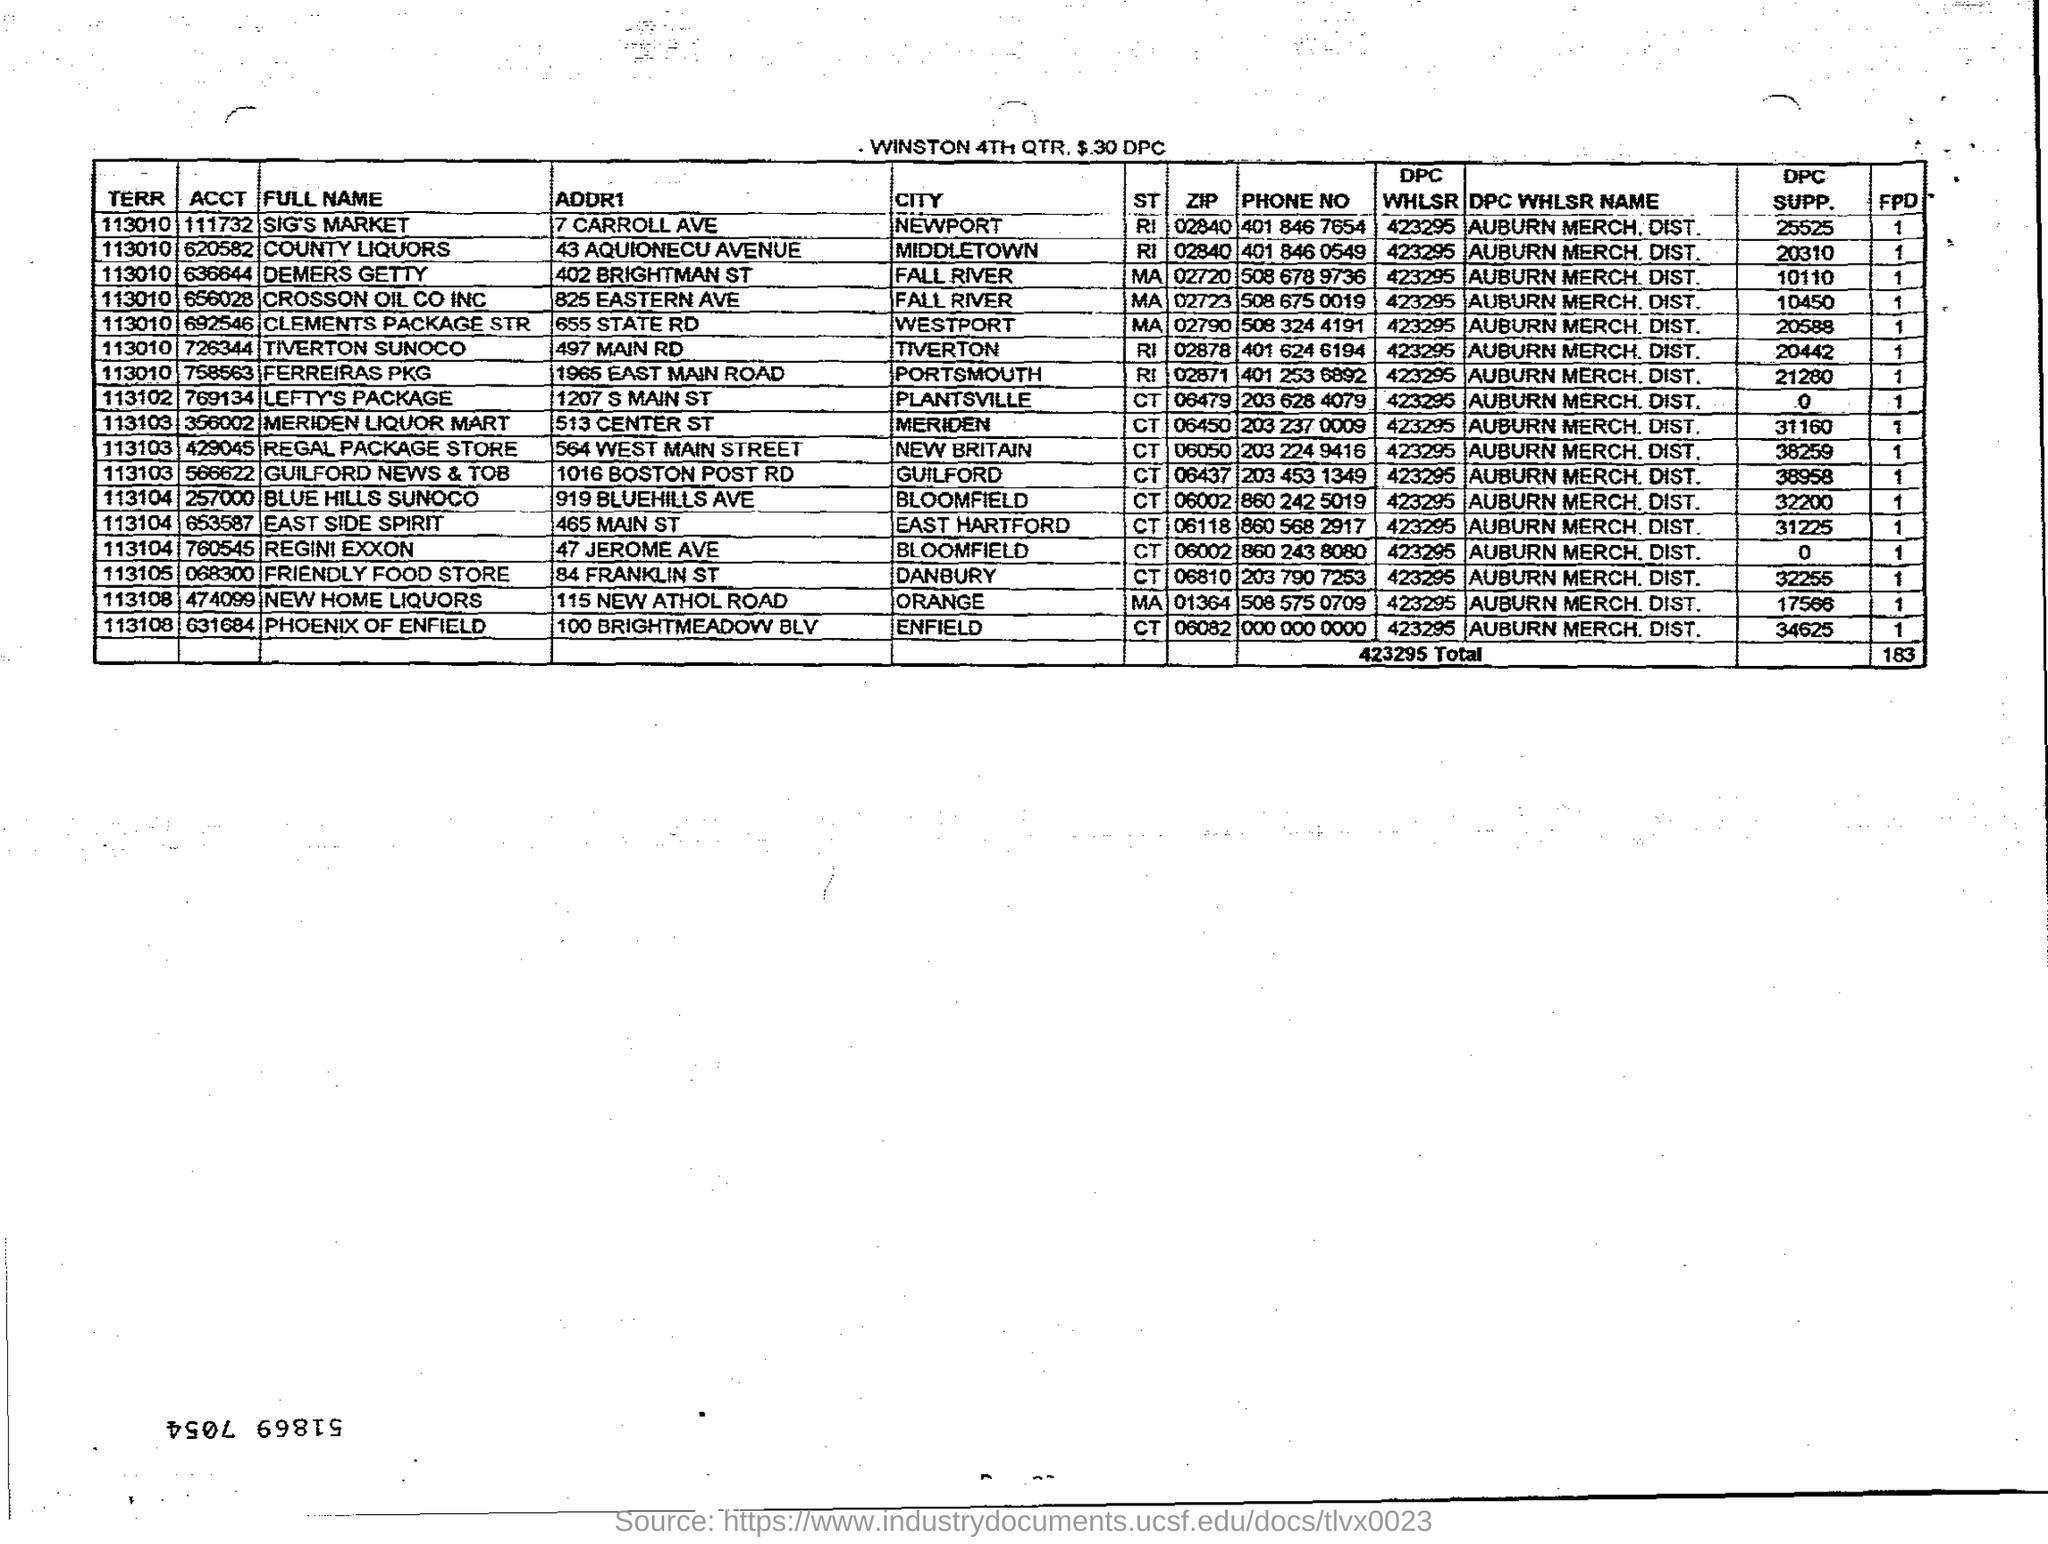What is the ACCT for County Liquors?
Offer a very short reply. 620582. What is the ACCT for Lefty's Package?
Offer a very short reply. 769134. What is the ACCT for Regini Exxon?
Give a very brief answer. 760545. What is the ACCT for Friendly Food Store?
Offer a very short reply. 068300. What is the City for Regini Exxon?
Make the answer very short. Bloomfield. What is the City for Friendly Food Store?
Give a very brief answer. DANBURY. What is the City for Lefty's Package?
Your answer should be compact. Plantsville. What is the DPC SUPP. for County Liquors?
Provide a succinct answer. 20310. What is the DPC SUPP. for Demers Getty?
Offer a very short reply. 10110. What is the DPC SUPP. for Sig's Market?
Provide a short and direct response. 25525. 